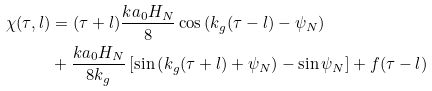Convert formula to latex. <formula><loc_0><loc_0><loc_500><loc_500>\chi ( \tau , l ) & = ( \tau + l ) \frac { k a _ { 0 } H _ { N } } { 8 } \cos \left ( k _ { g } ( \tau - l ) - \psi _ { N } \right ) \\ & + \frac { k a _ { 0 } H _ { N } } { 8 k _ { g } } \left [ \sin \left ( k _ { g } ( \tau + l ) + \psi _ { N } \right ) - \sin \psi _ { N } \right ] + f ( \tau - l )</formula> 